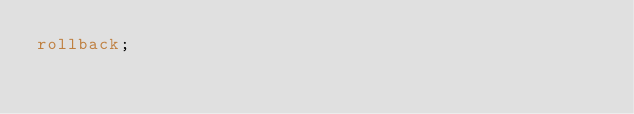<code> <loc_0><loc_0><loc_500><loc_500><_SQL_>rollback;
</code> 